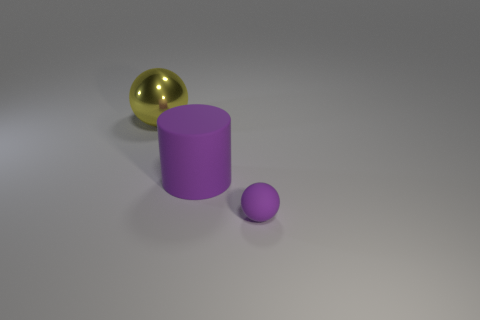Are there fewer small matte balls than gray blocks?
Give a very brief answer. No. What is the thing that is both in front of the large yellow thing and behind the small ball made of?
Provide a short and direct response. Rubber. There is a ball in front of the big yellow metal thing; is there a matte cylinder to the left of it?
Offer a terse response. Yes. What number of things are either large yellow objects or purple rubber balls?
Give a very brief answer. 2. The thing that is on the left side of the tiny ball and on the right side of the big yellow metal thing has what shape?
Give a very brief answer. Cylinder. Is the material of the ball that is behind the tiny purple matte sphere the same as the big purple cylinder?
Provide a succinct answer. No. What number of things are either blue objects or large objects that are in front of the yellow metal ball?
Your answer should be compact. 1. There is a big cylinder that is the same material as the tiny object; what color is it?
Your answer should be compact. Purple. What number of other purple spheres are the same material as the small ball?
Your answer should be compact. 0. What number of yellow metal things are there?
Make the answer very short. 1. 